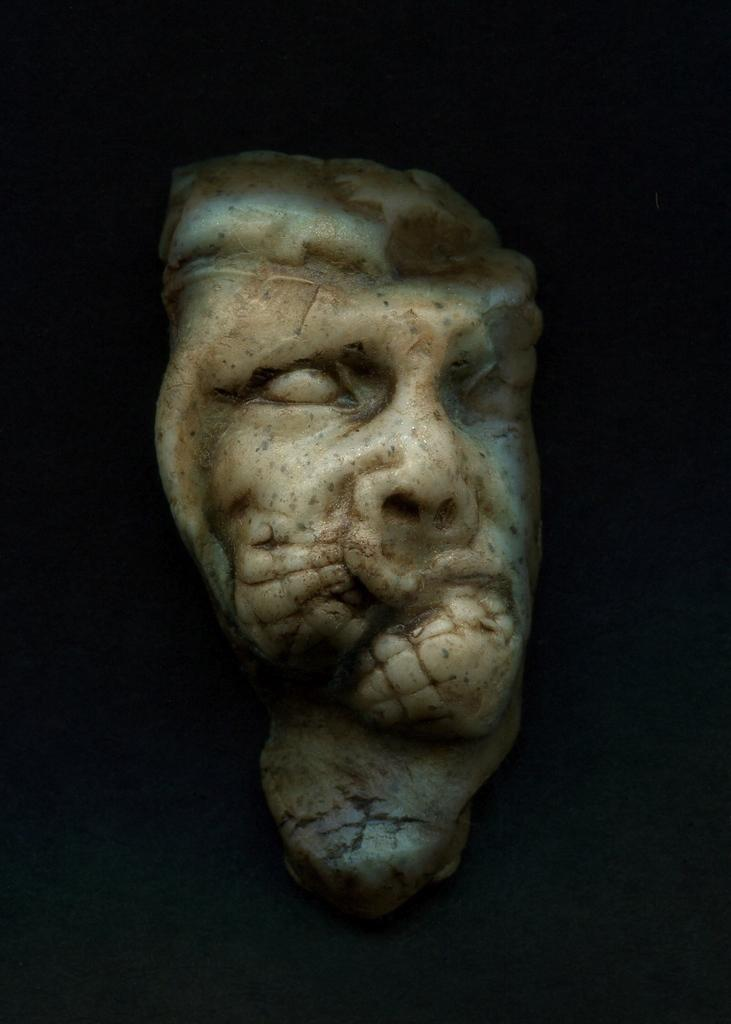What is the main subject of the image? There is a sculpture in the center of the image. Can you describe the background of the image? There is a wall visible in the background of the image. How many keys are used to unlock the egg in the image? There is no egg or key present in the image. What level of expertise is required to create the sculpture in the image? The level of expertise required to create the sculpture cannot be determined from the image alone. 